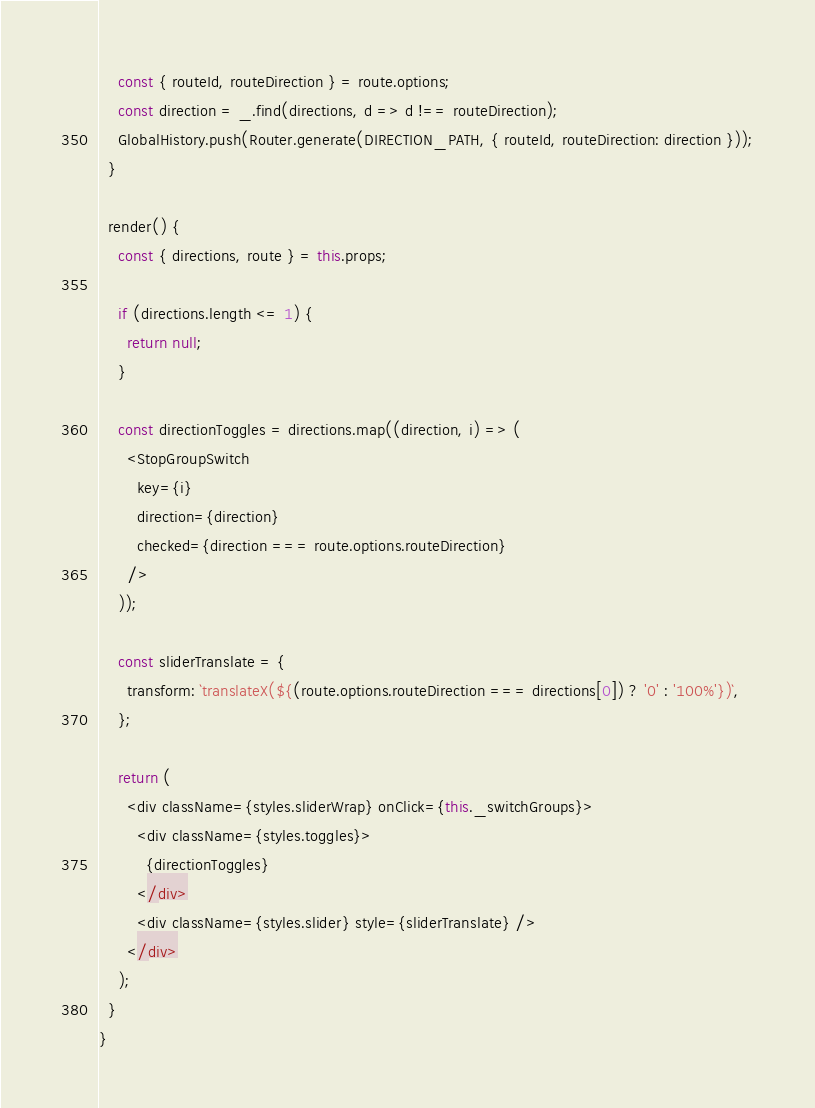<code> <loc_0><loc_0><loc_500><loc_500><_JavaScript_>    const { routeId, routeDirection } = route.options;
    const direction = _.find(directions, d => d !== routeDirection);
    GlobalHistory.push(Router.generate(DIRECTION_PATH, { routeId, routeDirection: direction }));
  }

  render() {
    const { directions, route } = this.props;

    if (directions.length <= 1) {
      return null;
    }

    const directionToggles = directions.map((direction, i) => (
      <StopGroupSwitch
        key={i}
        direction={direction}
        checked={direction === route.options.routeDirection}
      />
    ));

    const sliderTranslate = {
      transform: `translateX(${(route.options.routeDirection === directions[0]) ? '0' : '100%'})`,
    };

    return (
      <div className={styles.sliderWrap} onClick={this._switchGroups}>
        <div className={styles.toggles}>
          {directionToggles}
        </div>
        <div className={styles.slider} style={sliderTranslate} />
      </div>
    );
  }
}
</code> 